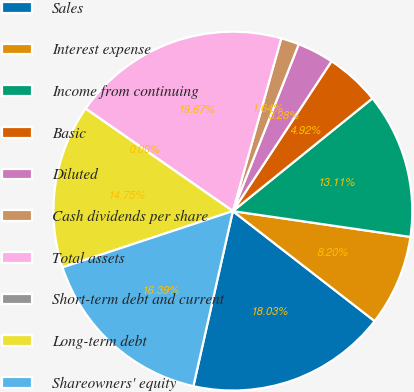<chart> <loc_0><loc_0><loc_500><loc_500><pie_chart><fcel>Sales<fcel>Interest expense<fcel>Income from continuing<fcel>Basic<fcel>Diluted<fcel>Cash dividends per share<fcel>Total assets<fcel>Short-term debt and current<fcel>Long-term debt<fcel>Shareowners' equity<nl><fcel>18.03%<fcel>8.2%<fcel>13.11%<fcel>4.92%<fcel>3.28%<fcel>1.64%<fcel>19.67%<fcel>0.0%<fcel>14.75%<fcel>16.39%<nl></chart> 